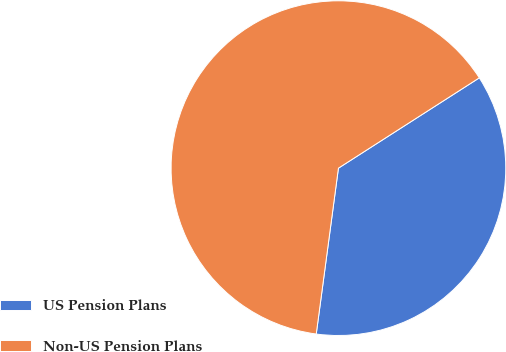Convert chart. <chart><loc_0><loc_0><loc_500><loc_500><pie_chart><fcel>US Pension Plans<fcel>Non-US Pension Plans<nl><fcel>36.19%<fcel>63.81%<nl></chart> 